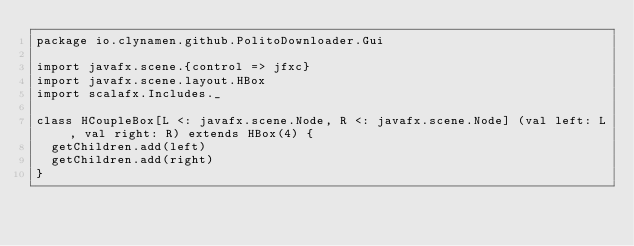<code> <loc_0><loc_0><loc_500><loc_500><_Scala_>package io.clynamen.github.PolitoDownloader.Gui

import javafx.scene.{control => jfxc}
import javafx.scene.layout.HBox
import scalafx.Includes._

class HCoupleBox[L <: javafx.scene.Node, R <: javafx.scene.Node] (val left: L, val right: R) extends HBox(4) {
  getChildren.add(left)
  getChildren.add(right)
}
</code> 